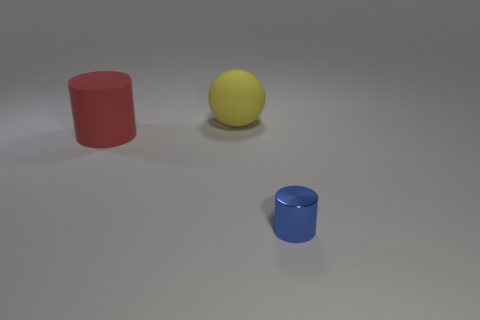Can you describe the overall composition and balance of the image? The composition shows three simple geometric shapes with primary colors evenly spaced on a neutral gray background. The arrangement creates a balanced and minimalist aesthetic. 